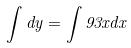Convert formula to latex. <formula><loc_0><loc_0><loc_500><loc_500>\int d y = \int 9 3 x d x</formula> 